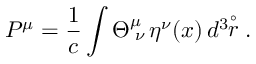Convert formula to latex. <formula><loc_0><loc_0><loc_500><loc_500>P ^ { \mu } = \frac { 1 } { c } \int \Theta _ { \, \nu } ^ { \mu } \, \eta ^ { \nu } ( x ) \, d ^ { 3 } \, \stackrel { \circ } { r } .</formula> 